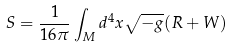Convert formula to latex. <formula><loc_0><loc_0><loc_500><loc_500>S = \frac { 1 } { 1 6 \pi } \int _ { M } d ^ { 4 } x \sqrt { - g } ( R + W )</formula> 